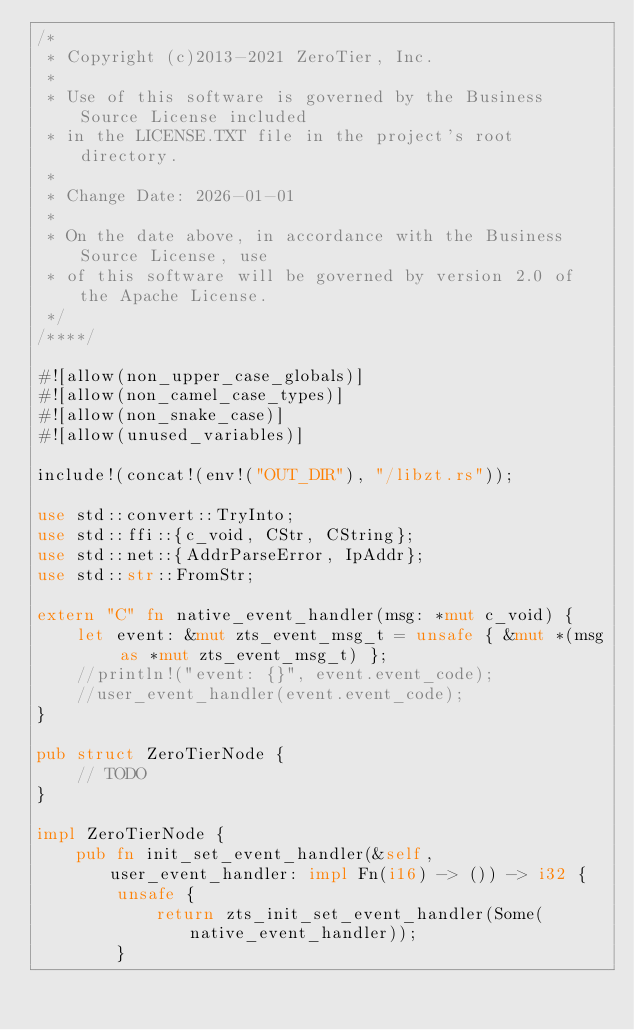<code> <loc_0><loc_0><loc_500><loc_500><_Rust_>/*
 * Copyright (c)2013-2021 ZeroTier, Inc.
 *
 * Use of this software is governed by the Business Source License included
 * in the LICENSE.TXT file in the project's root directory.
 *
 * Change Date: 2026-01-01
 *
 * On the date above, in accordance with the Business Source License, use
 * of this software will be governed by version 2.0 of the Apache License.
 */
/****/

#![allow(non_upper_case_globals)]
#![allow(non_camel_case_types)]
#![allow(non_snake_case)]
#![allow(unused_variables)]

include!(concat!(env!("OUT_DIR"), "/libzt.rs"));

use std::convert::TryInto;
use std::ffi::{c_void, CStr, CString};
use std::net::{AddrParseError, IpAddr};
use std::str::FromStr;

extern "C" fn native_event_handler(msg: *mut c_void) {
    let event: &mut zts_event_msg_t = unsafe { &mut *(msg as *mut zts_event_msg_t) };
    //println!("event: {}", event.event_code);
    //user_event_handler(event.event_code);
}

pub struct ZeroTierNode {
    // TODO
}

impl ZeroTierNode {
    pub fn init_set_event_handler(&self, user_event_handler: impl Fn(i16) -> ()) -> i32 {
        unsafe {
            return zts_init_set_event_handler(Some(native_event_handler));
        }</code> 